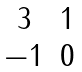Convert formula to latex. <formula><loc_0><loc_0><loc_500><loc_500>\begin{matrix} 3 & 1 \\ - 1 & 0 \end{matrix}</formula> 